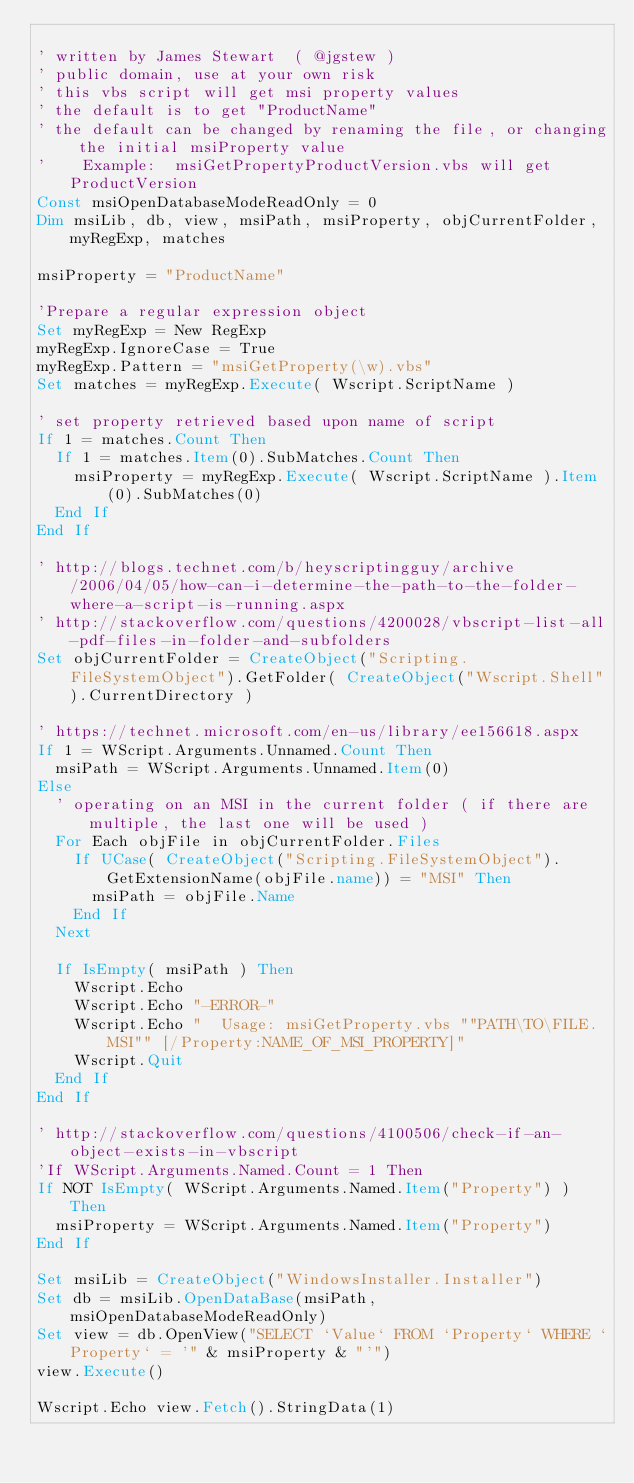Convert code to text. <code><loc_0><loc_0><loc_500><loc_500><_VisualBasic_>
' written by James Stewart  ( @jgstew )
' public domain, use at your own risk
' this vbs script will get msi property values
' the default is to get "ProductName"
' the default can be changed by renaming the file, or changing the initial msiProperty value
'    Example:  msiGetPropertyProductVersion.vbs will get ProductVersion
Const msiOpenDatabaseModeReadOnly = 0
Dim msiLib, db, view, msiPath, msiProperty, objCurrentFolder, myRegExp, matches

msiProperty = "ProductName"

'Prepare a regular expression object
Set myRegExp = New RegExp
myRegExp.IgnoreCase = True
myRegExp.Pattern = "msiGetProperty(\w).vbs"
Set matches = myRegExp.Execute( Wscript.ScriptName )

' set property retrieved based upon name of script
If 1 = matches.Count Then
	If 1 = matches.Item(0).SubMatches.Count Then
		msiProperty = myRegExp.Execute( Wscript.ScriptName ).Item(0).SubMatches(0)
	End If
End If

' http://blogs.technet.com/b/heyscriptingguy/archive/2006/04/05/how-can-i-determine-the-path-to-the-folder-where-a-script-is-running.aspx
' http://stackoverflow.com/questions/4200028/vbscript-list-all-pdf-files-in-folder-and-subfolders
Set objCurrentFolder = CreateObject("Scripting.FileSystemObject").GetFolder( CreateObject("Wscript.Shell").CurrentDirectory )

' https://technet.microsoft.com/en-us/library/ee156618.aspx
If 1 = WScript.Arguments.Unnamed.Count Then
	msiPath = WScript.Arguments.Unnamed.Item(0)
Else
	' operating on an MSI in the current folder ( if there are multiple, the last one will be used )
	For Each objFile in objCurrentFolder.Files
		If UCase( CreateObject("Scripting.FileSystemObject").GetExtensionName(objFile.name)) = "MSI" Then
			msiPath = objFile.Name
		End If
	Next
	
	If IsEmpty( msiPath ) Then
		Wscript.Echo
		Wscript.Echo "-ERROR-"
		Wscript.Echo "  Usage: msiGetProperty.vbs ""PATH\TO\FILE.MSI"" [/Property:NAME_OF_MSI_PROPERTY]"
		Wscript.Quit
	End If
End If

' http://stackoverflow.com/questions/4100506/check-if-an-object-exists-in-vbscript
'If WScript.Arguments.Named.Count = 1 Then
If NOT IsEmpty( WScript.Arguments.Named.Item("Property") ) Then
	msiProperty = WScript.Arguments.Named.Item("Property")
End If

Set msiLib = CreateObject("WindowsInstaller.Installer")
Set db = msiLib.OpenDataBase(msiPath, msiOpenDatabaseModeReadOnly)
Set view = db.OpenView("SELECT `Value` FROM `Property` WHERE `Property` = '" & msiProperty & "'")
view.Execute()

Wscript.Echo view.Fetch().StringData(1)
</code> 